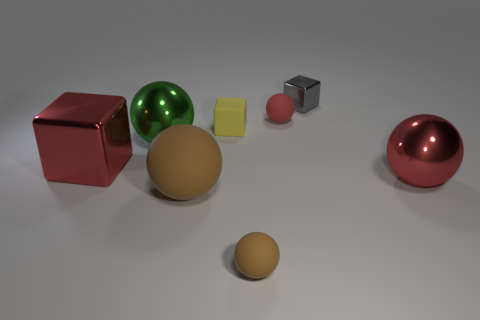Subtract all green spheres. How many spheres are left? 4 Subtract all large red metal spheres. How many spheres are left? 4 Subtract all green balls. Subtract all brown cubes. How many balls are left? 4 Subtract all large brown matte things. Subtract all small brown balls. How many objects are left? 6 Add 7 big brown matte objects. How many big brown matte objects are left? 8 Add 7 metallic blocks. How many metallic blocks exist? 9 Subtract 0 gray cylinders. How many objects are left? 8 Subtract all blocks. How many objects are left? 5 